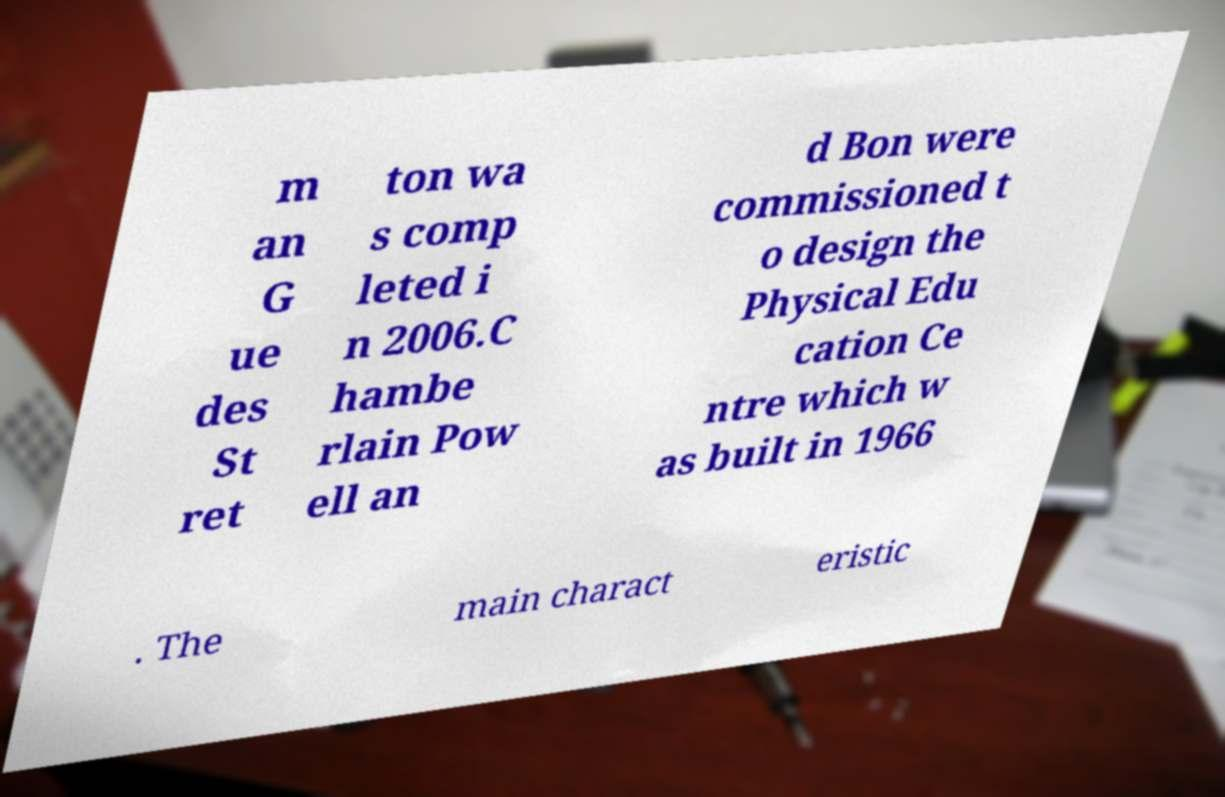Please read and relay the text visible in this image. What does it say? m an G ue des St ret ton wa s comp leted i n 2006.C hambe rlain Pow ell an d Bon were commissioned t o design the Physical Edu cation Ce ntre which w as built in 1966 . The main charact eristic 